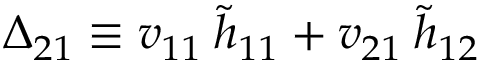Convert formula to latex. <formula><loc_0><loc_0><loc_500><loc_500>\Delta _ { 2 1 } \equiv v _ { 1 1 } \, \tilde { h } _ { 1 1 } + v _ { 2 1 } \, \tilde { h } _ { 1 2 }</formula> 